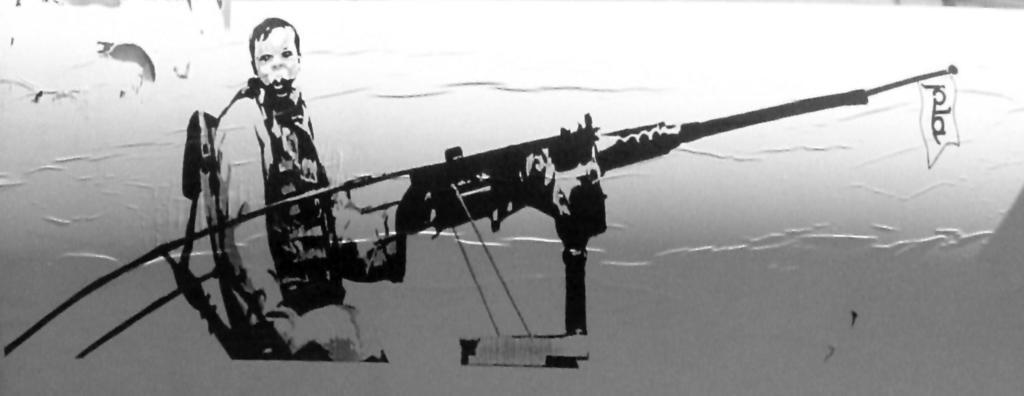What is the main subject of the image? There is an art piece in the image. What does the art piece depict? The art piece depicts a person. What is the person holding in the art piece? The person is holding a weapon. What is the person's desire in the art piece? The image does not provide information about the person's desires, as it only shows a depiction of a person holding a weapon. 